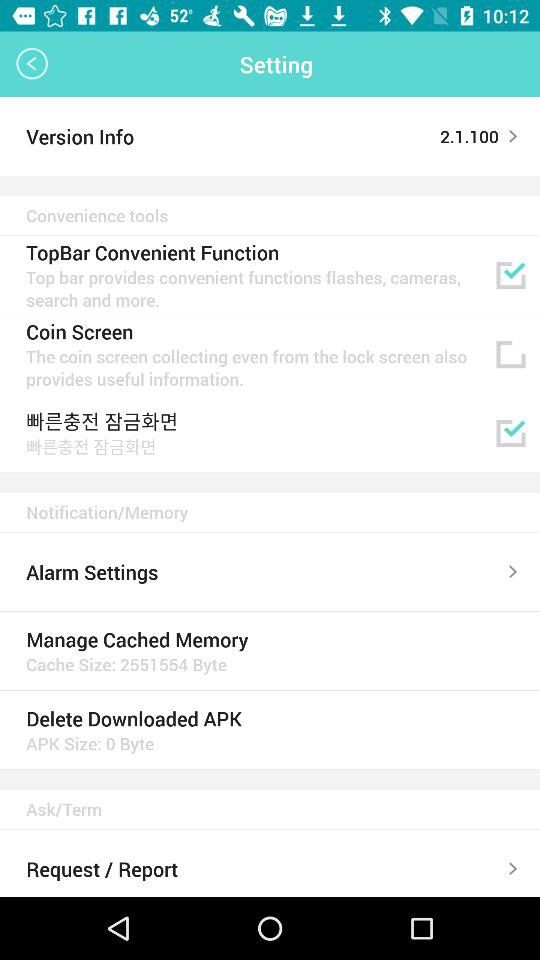What is the size of the "Delete Downloaded APK" file? The size is 0 byte. 